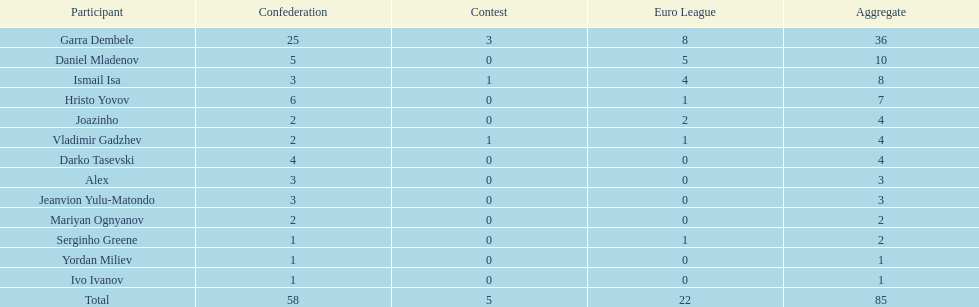How many of the players did not score any goals in the cup? 10. 